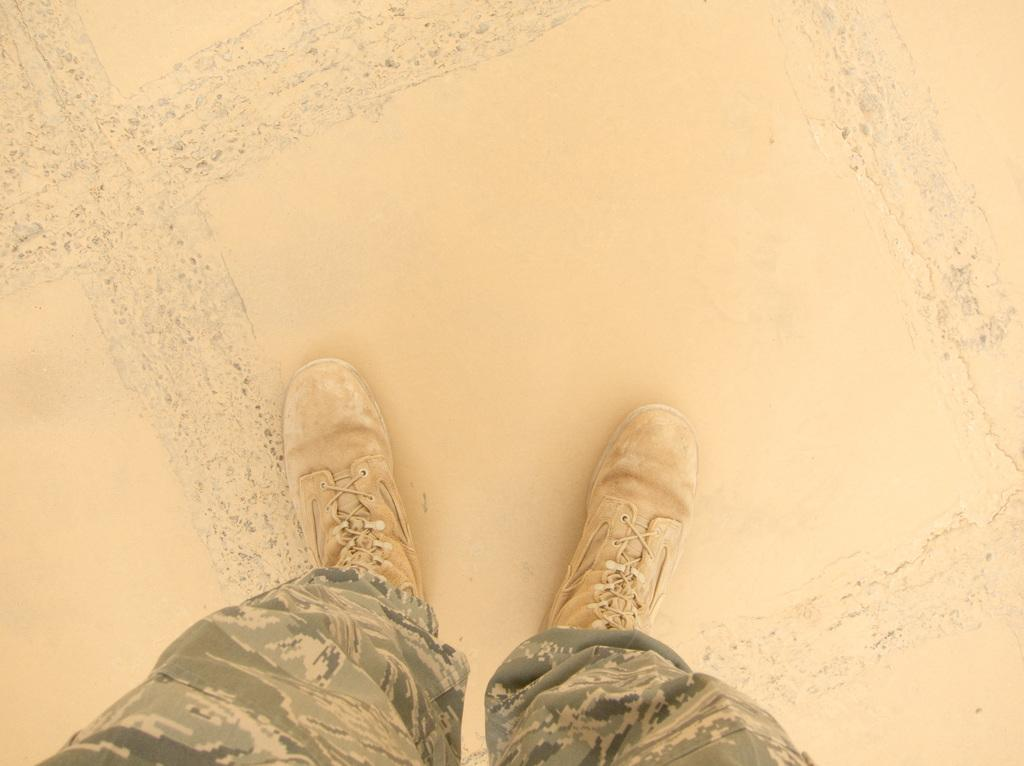What body parts are visible in the image? There are person's legs visible in the image. What is the surface on which the person's legs are placed? The person's legs are on a surface. How much of the person's legs can be seen in the image? The person's legs are truncated towards the bottom of the image. Is the person's legs hot in the image? There is no information about the temperature of the person's legs in the image, so we cannot determine if they are hot or not. 